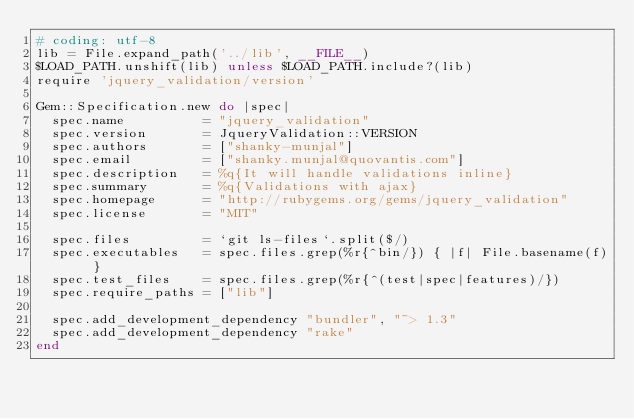<code> <loc_0><loc_0><loc_500><loc_500><_Ruby_># coding: utf-8
lib = File.expand_path('../lib', __FILE__)
$LOAD_PATH.unshift(lib) unless $LOAD_PATH.include?(lib)
require 'jquery_validation/version'

Gem::Specification.new do |spec|
  spec.name          = "jquery_validation"
  spec.version       = JqueryValidation::VERSION
  spec.authors       = ["shanky-munjal"]
  spec.email         = ["shanky.munjal@quovantis.com"]
  spec.description   = %q{It will handle validations inline}
  spec.summary       = %q{Validations with ajax}
  spec.homepage      = "http://rubygems.org/gems/jquery_validation"
  spec.license       = "MIT"

  spec.files         = `git ls-files`.split($/)
  spec.executables   = spec.files.grep(%r{^bin/}) { |f| File.basename(f) }
  spec.test_files    = spec.files.grep(%r{^(test|spec|features)/})
  spec.require_paths = ["lib"]

  spec.add_development_dependency "bundler", "~> 1.3"
  spec.add_development_dependency "rake"
end
</code> 